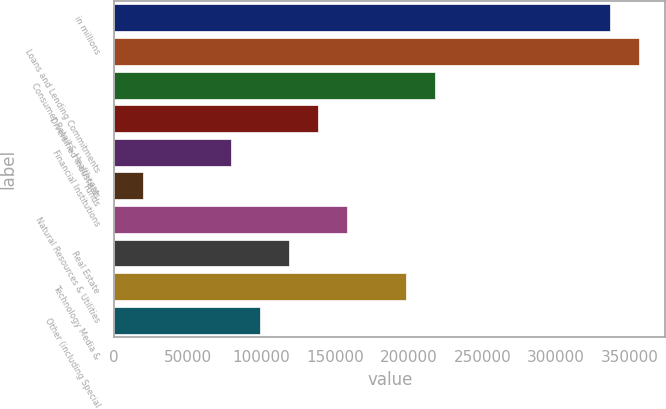Convert chart. <chart><loc_0><loc_0><loc_500><loc_500><bar_chart><fcel>in millions<fcel>Loans and Lending Commitments<fcel>Consumer Retail & Healthcare<fcel>Diversified Industrials<fcel>Financial Institutions<fcel>Funds<fcel>Natural Resources & Utilities<fcel>Real Estate<fcel>Technology Media &<fcel>Other (including Special<nl><fcel>336619<fcel>356420<fcel>217813<fcel>138609<fcel>79206<fcel>19803<fcel>158410<fcel>118808<fcel>198012<fcel>99007<nl></chart> 